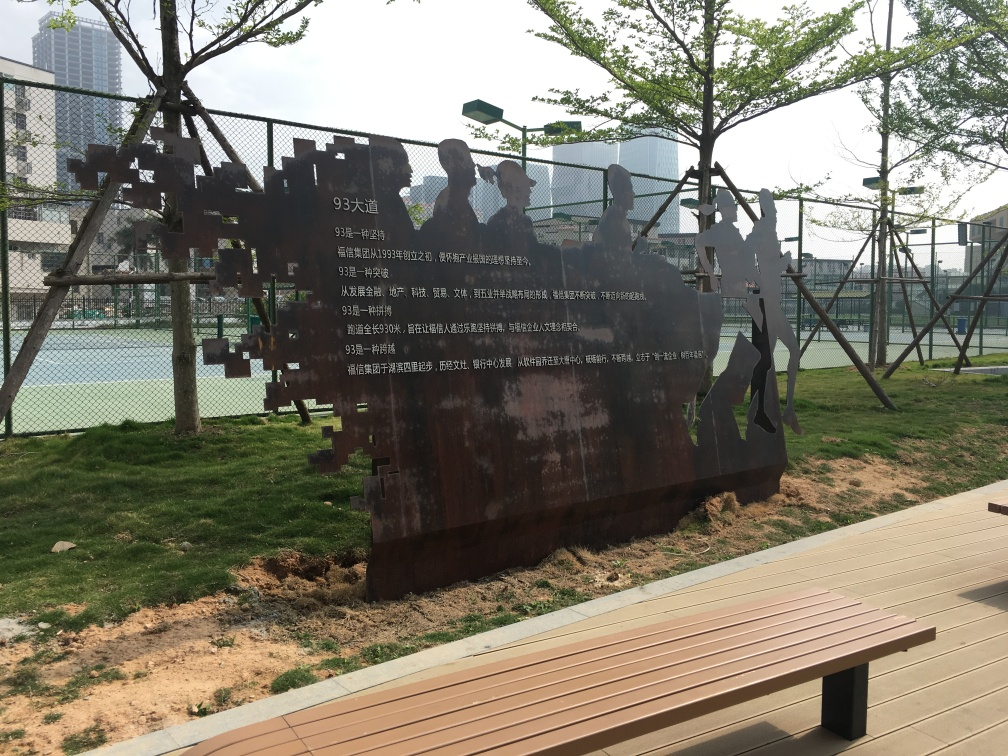How would you describe the texture details of the trees?
A. Rich
B. Indistinct
C. Blurry
Answer with the option's letter from the given choices directly.
 A. 